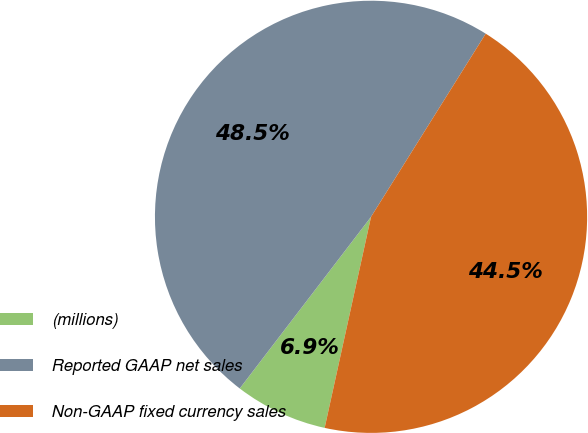Convert chart to OTSL. <chart><loc_0><loc_0><loc_500><loc_500><pie_chart><fcel>(millions)<fcel>Reported GAAP net sales<fcel>Non-GAAP fixed currency sales<nl><fcel>6.95%<fcel>48.51%<fcel>44.54%<nl></chart> 